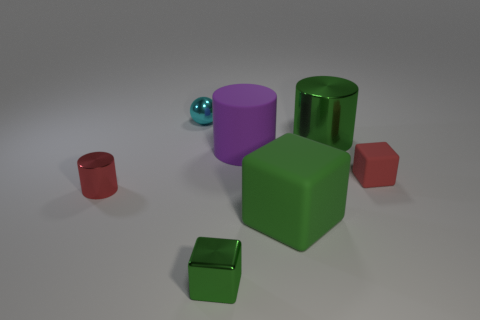What shape is the rubber object that is the same color as the small cylinder?
Your response must be concise. Cube. There is a cyan thing; how many big matte cubes are behind it?
Provide a short and direct response. 0. Is the shape of the cyan object the same as the large green matte thing?
Your response must be concise. No. What number of metal cylinders are both right of the sphere and in front of the large purple cylinder?
Make the answer very short. 0. What number of things are either rubber blocks or metallic things that are to the left of the small shiny cube?
Your response must be concise. 4. Is the number of red blocks greater than the number of big blue things?
Provide a short and direct response. Yes. The matte thing to the right of the big metallic cylinder has what shape?
Offer a very short reply. Cube. How many cyan things have the same shape as the large purple matte object?
Offer a terse response. 0. There is a green shiny object that is to the left of the green thing that is on the right side of the large green cube; what is its size?
Offer a terse response. Small. How many cyan objects are either rubber blocks or matte spheres?
Your answer should be very brief. 0. 